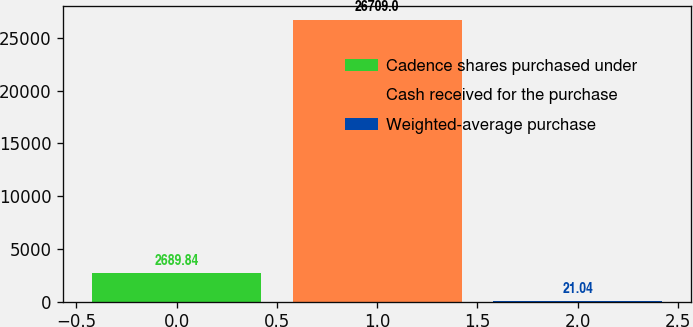Convert chart. <chart><loc_0><loc_0><loc_500><loc_500><bar_chart><fcel>Cadence shares purchased under<fcel>Cash received for the purchase<fcel>Weighted-average purchase<nl><fcel>2689.84<fcel>26709<fcel>21.04<nl></chart> 